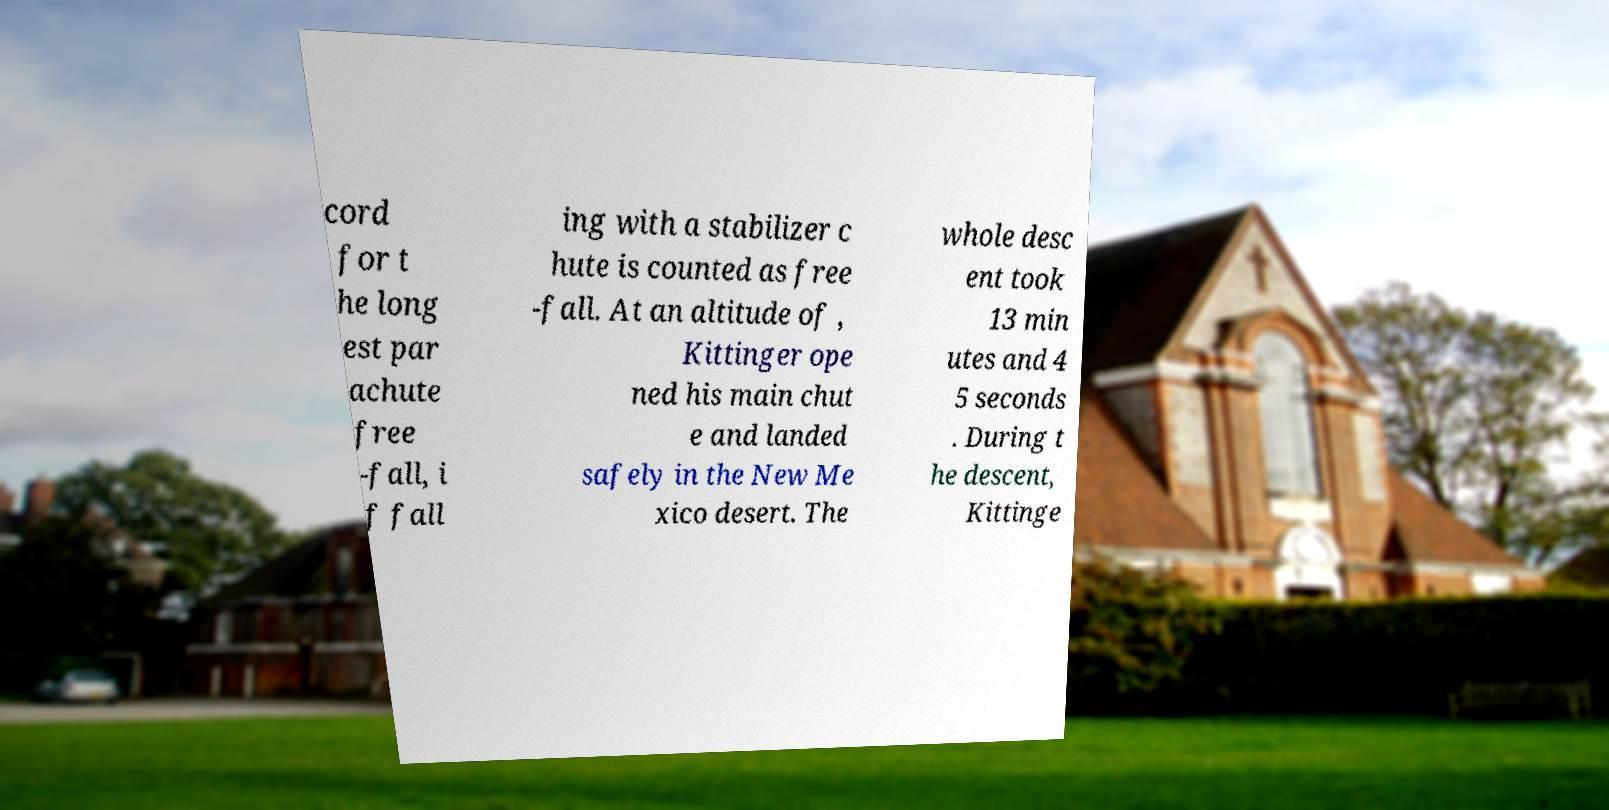Could you extract and type out the text from this image? cord for t he long est par achute free -fall, i f fall ing with a stabilizer c hute is counted as free -fall. At an altitude of , Kittinger ope ned his main chut e and landed safely in the New Me xico desert. The whole desc ent took 13 min utes and 4 5 seconds . During t he descent, Kittinge 